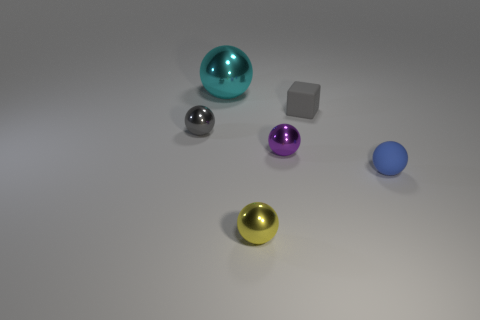Subtract all rubber spheres. How many spheres are left? 4 Subtract 2 balls. How many balls are left? 3 Subtract all purple balls. How many balls are left? 4 Add 1 blue rubber things. How many objects exist? 7 Subtract all red balls. Subtract all brown cylinders. How many balls are left? 5 Subtract all spheres. How many objects are left? 1 Subtract 0 brown cylinders. How many objects are left? 6 Subtract all big green balls. Subtract all tiny objects. How many objects are left? 1 Add 4 cyan balls. How many cyan balls are left? 5 Add 4 blue metallic balls. How many blue metallic balls exist? 4 